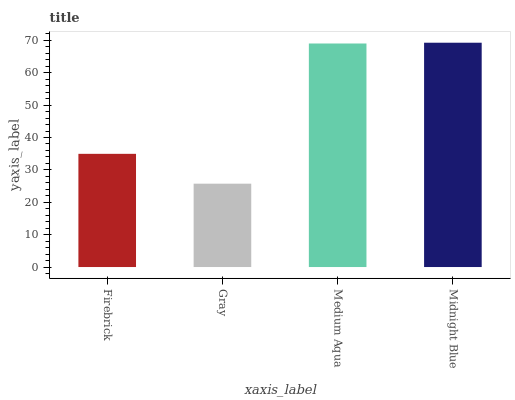Is Gray the minimum?
Answer yes or no. Yes. Is Midnight Blue the maximum?
Answer yes or no. Yes. Is Medium Aqua the minimum?
Answer yes or no. No. Is Medium Aqua the maximum?
Answer yes or no. No. Is Medium Aqua greater than Gray?
Answer yes or no. Yes. Is Gray less than Medium Aqua?
Answer yes or no. Yes. Is Gray greater than Medium Aqua?
Answer yes or no. No. Is Medium Aqua less than Gray?
Answer yes or no. No. Is Medium Aqua the high median?
Answer yes or no. Yes. Is Firebrick the low median?
Answer yes or no. Yes. Is Firebrick the high median?
Answer yes or no. No. Is Medium Aqua the low median?
Answer yes or no. No. 